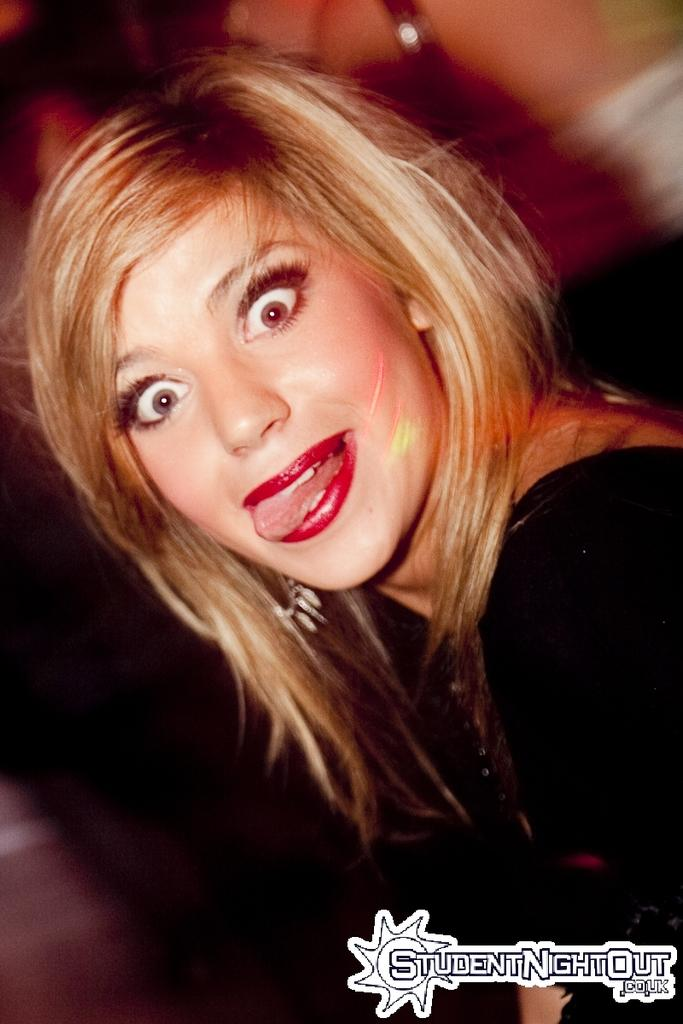Who is present in the image? There is a lady in the image. What can be seen in the right bottom corner of the image? There is a watermark in the right bottom corner of the image. How would you describe the background of the image? The background of the image is blurry. What type of meat is being served on the plate in the image? There is no plate or meat present in the image; it features a lady with a blurry background and a watermark in the right bottom corner. 